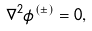Convert formula to latex. <formula><loc_0><loc_0><loc_500><loc_500>\nabla ^ { 2 } \phi ^ { ( \pm ) } = 0 ,</formula> 